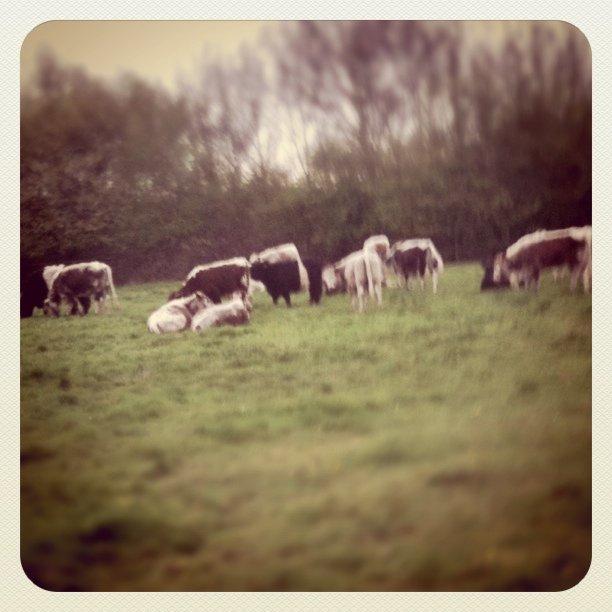How many cows are there?
Answer briefly. 10. Is the picture clear?
Concise answer only. No. Are any of the cows lying down?
Give a very brief answer. Yes. 